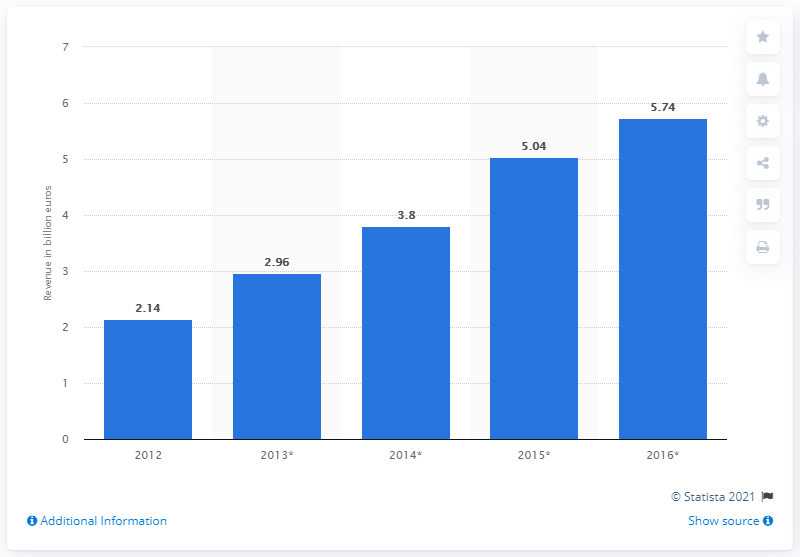Give some essential details in this illustration. In 2012, the video on demand service revenue was released in Japan. In 2014, the estimated amount of Japanese VoD service revenue was approximately 3.8 billion yen. 